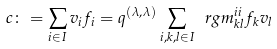<formula> <loc_0><loc_0><loc_500><loc_500>c \colon = \sum _ { i \in I } v _ { i } f _ { i } = q ^ { ( \lambda , \lambda ) } \sum _ { i , k , l \in I } \ r g m ^ { i i } _ { k l } f _ { k } v _ { l }</formula> 